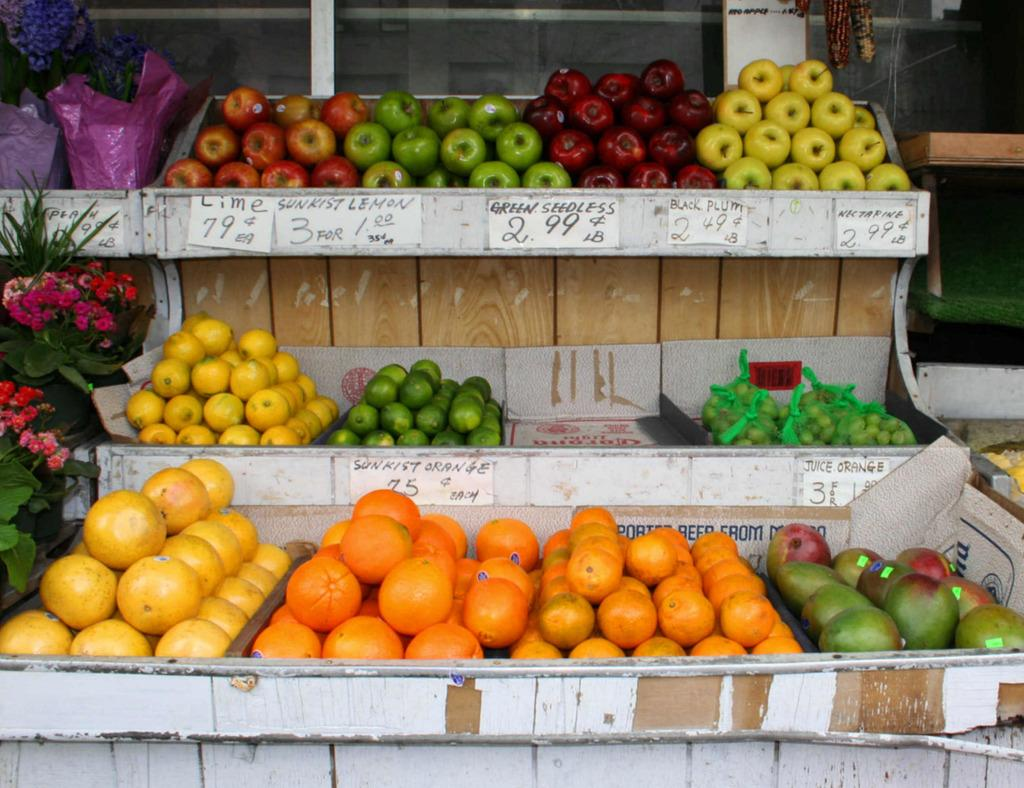What type of fruits can be seen in the image? There are apples and oranges in the image. Can you describe the arrangement of the fruits and flower bouquets? The fruits and flower bouquets are in baskets. What other objects are present in the image besides fruits and flower bouquets? There are objects in the image, but their specific nature is not mentioned in the provided facts. How does the nose of the person in the image turn when they smell the fruits? There is no person present in the image, so there is no nose to turn when smelling the fruits. 